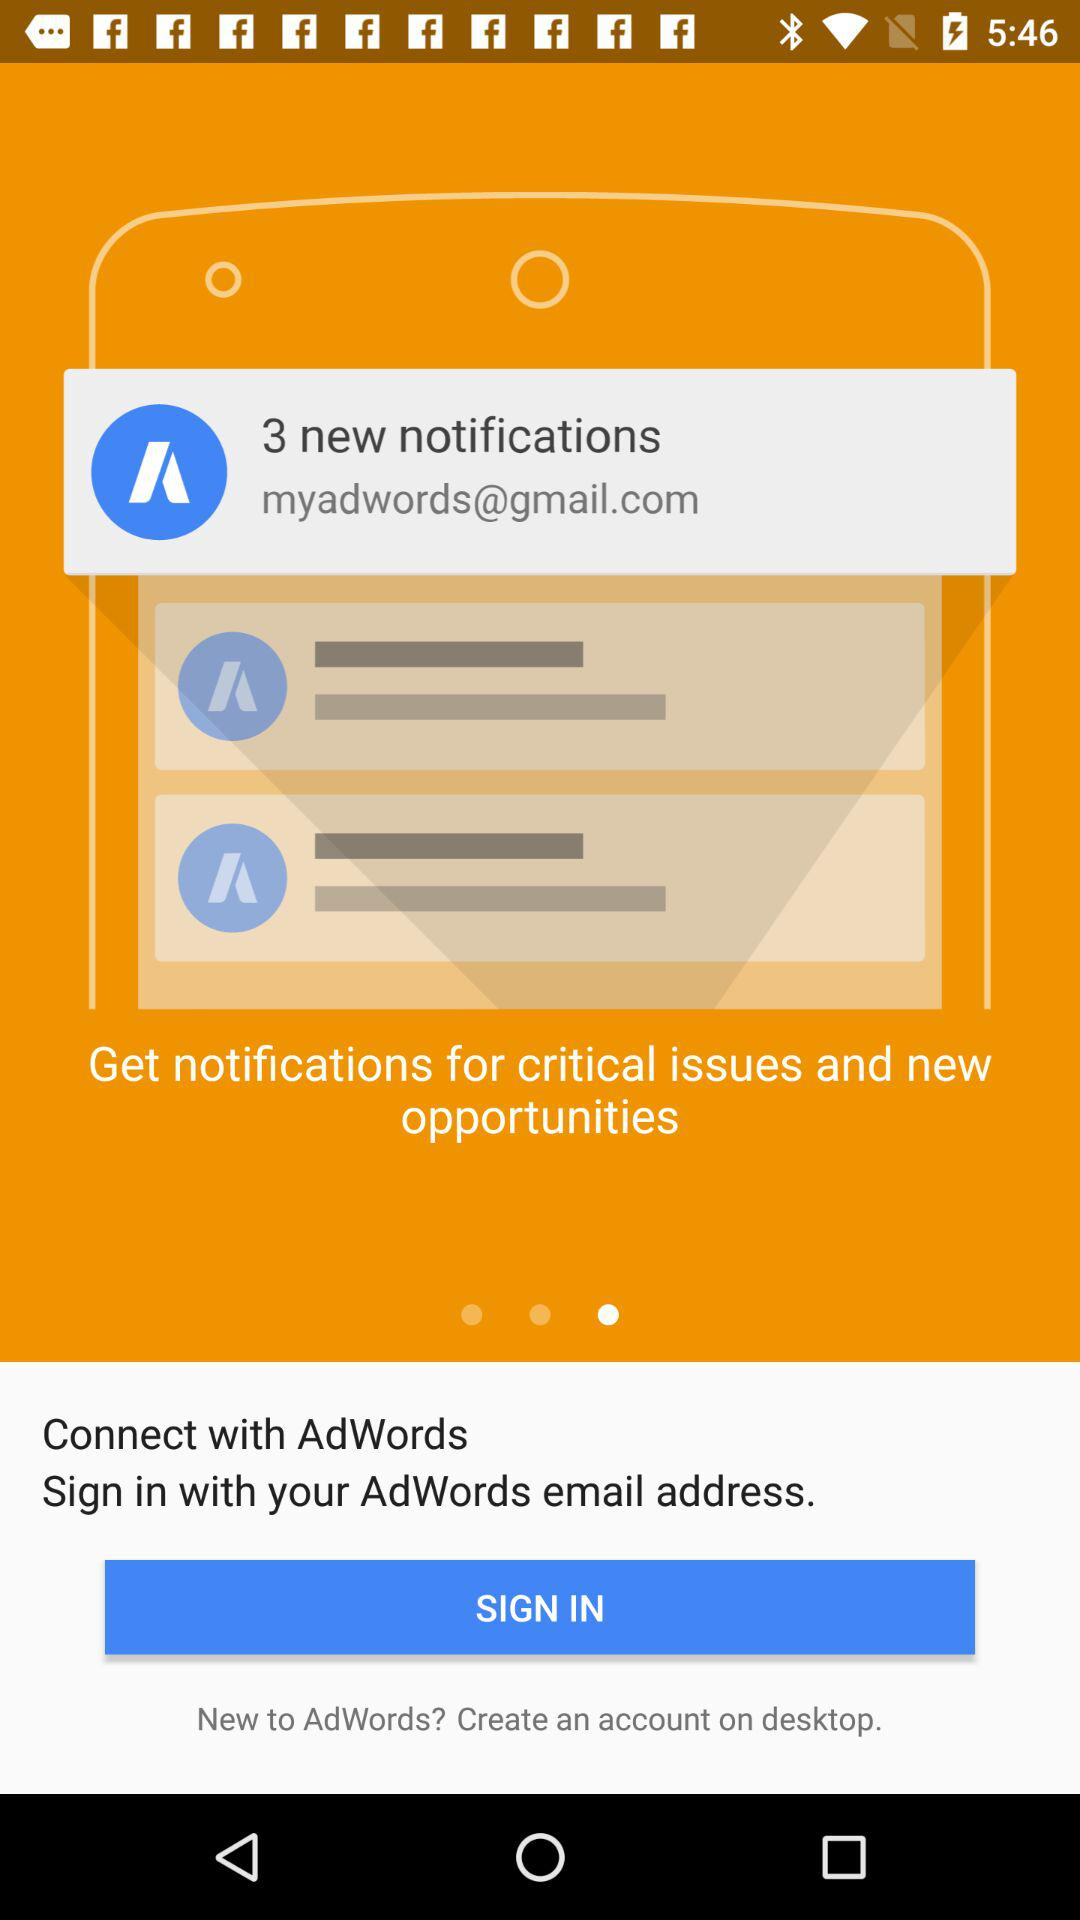How many new notifications are there? There are 3 new notifications. 